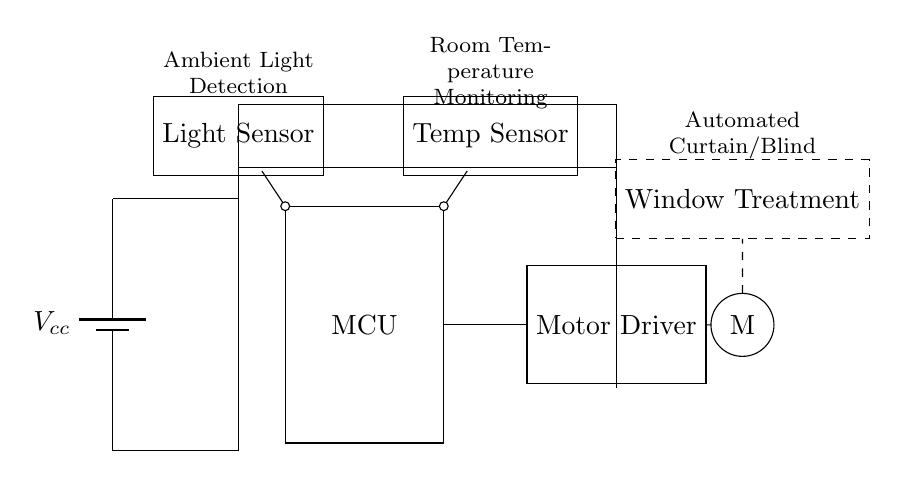What is the main power supply of this circuit? The main power supply is represented by the battery in the circuit diagram, labeled as Vcc. It provides the necessary voltage for the operation of the whole circuit.
Answer: Battery What components are used for environmental monitoring in this circuit? The circuit includes a light sensor and a temperature sensor, both of which monitor environmental conditions affecting the automated window treatments.
Answer: Light sensor and temperature sensor What is the function of the motor driver in this circuit? The motor driver regulates the power to the motor based on signals received from the microcontroller, allowing it to control the movement of the window treatment.
Answer: Controls motor How are the sensors connected to the microcontroller? The light sensor and temperature sensor are connected to the microcontroller through direct lines, allowing the sensors to communicate their readings to the microcontroller for processing.
Answer: Directly connected Which component is responsible for moving the window treatment? The motor is responsible for moving the window treatment, as it is the physical actuator that adjusts the position of the curtains or blinds.
Answer: Motor What type of circuit is represented in this diagram? The circuit is a hybrid system designed for automated control of window treatments, incorporating both analog sensing components (sensors) and digital processing (microcontroller).
Answer: Hybrid circuit 